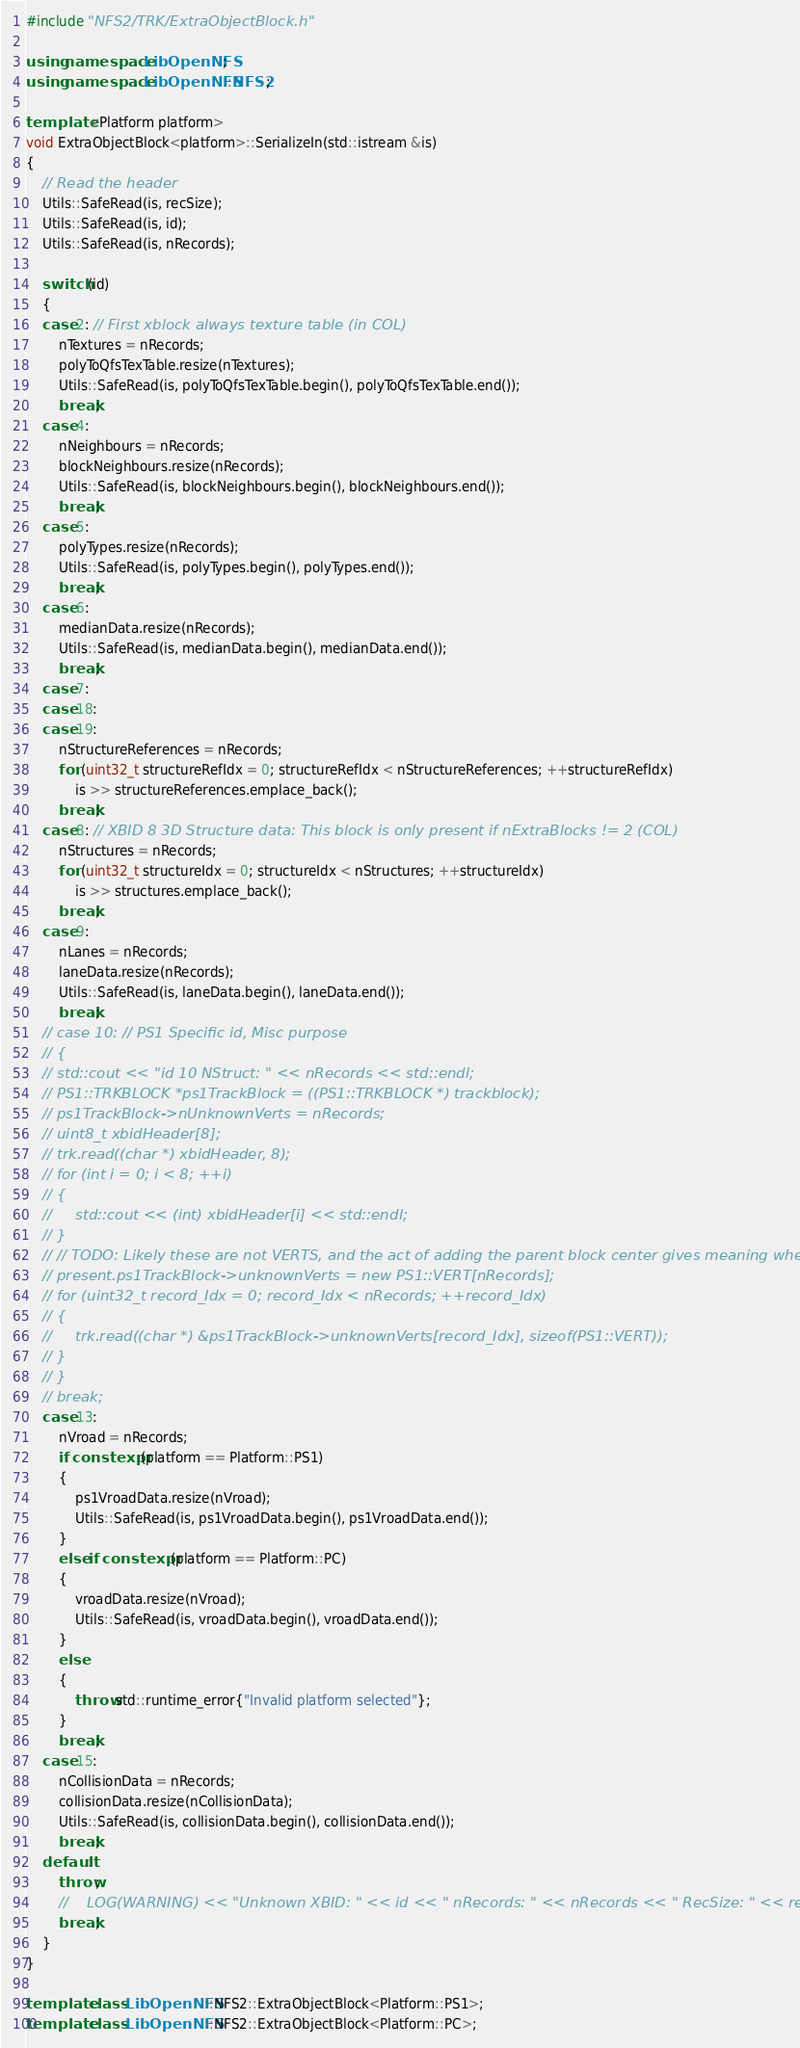<code> <loc_0><loc_0><loc_500><loc_500><_C++_>#include "NFS2/TRK/ExtraObjectBlock.h"

using namespace LibOpenNFS;
using namespace LibOpenNFS::NFS2;

template <Platform platform>
void ExtraObjectBlock<platform>::SerializeIn(std::istream &is)
{
    // Read the header
    Utils::SafeRead(is, recSize);
    Utils::SafeRead(is, id);
    Utils::SafeRead(is, nRecords);

    switch (id)
    {
    case 2: // First xblock always texture table (in COL)
        nTextures = nRecords;
        polyToQfsTexTable.resize(nTextures);
        Utils::SafeRead(is, polyToQfsTexTable.begin(), polyToQfsTexTable.end());
        break;
    case 4:
        nNeighbours = nRecords;
        blockNeighbours.resize(nRecords);
        Utils::SafeRead(is, blockNeighbours.begin(), blockNeighbours.end());
        break;
    case 5:
        polyTypes.resize(nRecords);
        Utils::SafeRead(is, polyTypes.begin(), polyTypes.end());
        break;
    case 6:
        medianData.resize(nRecords);
        Utils::SafeRead(is, medianData.begin(), medianData.end());
        break;
    case 7:
    case 18:
    case 19:
        nStructureReferences = nRecords;
        for (uint32_t structureRefIdx = 0; structureRefIdx < nStructureReferences; ++structureRefIdx)
            is >> structureReferences.emplace_back();
        break;
    case 8: // XBID 8 3D Structure data: This block is only present if nExtraBlocks != 2 (COL)
        nStructures = nRecords;
        for (uint32_t structureIdx = 0; structureIdx < nStructures; ++structureIdx)
            is >> structures.emplace_back();
        break;
    case 9:
        nLanes = nRecords;
        laneData.resize(nRecords);
        Utils::SafeRead(is, laneData.begin(), laneData.end());
        break;
    // case 10: // PS1 Specific id, Misc purpose
    // {
    // std::cout << "id 10 NStruct: " << nRecords << std::endl;
    // PS1::TRKBLOCK *ps1TrackBlock = ((PS1::TRKBLOCK *) trackblock);
    // ps1TrackBlock->nUnknownVerts = nRecords;
    // uint8_t xbidHeader[8];
    // trk.read((char *) xbidHeader, 8);
    // for (int i = 0; i < 8; ++i)
    // {
    //     std::cout << (int) xbidHeader[i] << std::endl;
    // }
    // // TODO: Likely these are not VERTS, and the act of adding the parent block center gives meaning where none is
    // present.ps1TrackBlock->unknownVerts = new PS1::VERT[nRecords];
    // for (uint32_t record_Idx = 0; record_Idx < nRecords; ++record_Idx)
    // {
    //     trk.read((char *) &ps1TrackBlock->unknownVerts[record_Idx], sizeof(PS1::VERT));
    // }
    // }
    // break;
    case 13:
        nVroad = nRecords;
        if constexpr (platform == Platform::PS1)
        {
            ps1VroadData.resize(nVroad);
            Utils::SafeRead(is, ps1VroadData.begin(), ps1VroadData.end());
        }
        else if constexpr (platform == Platform::PC)
        {
            vroadData.resize(nVroad);
            Utils::SafeRead(is, vroadData.begin(), vroadData.end());
        }
        else
        {
            throw std::runtime_error{"Invalid platform selected"};
        }
        break;
    case 15:
        nCollisionData = nRecords;
        collisionData.resize(nCollisionData);
        Utils::SafeRead(is, collisionData.begin(), collisionData.end());
        break;
    default:
        throw;
        //    LOG(WARNING) << "Unknown XBID: " << id << " nRecords: " << nRecords << " RecSize: " << recSize;
        break;
    }
}

template class LibOpenNFS::NFS2::ExtraObjectBlock<Platform::PS1>;
template class LibOpenNFS::NFS2::ExtraObjectBlock<Platform::PC>;
</code> 